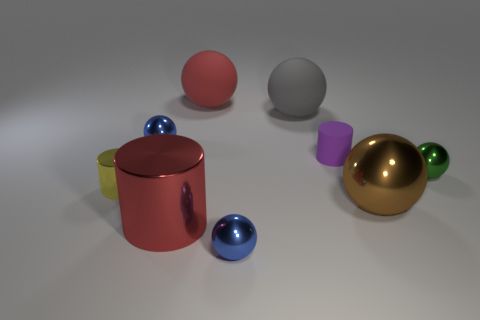Subtract all brown spheres. How many spheres are left? 5 Subtract all green balls. How many balls are left? 5 Subtract all purple balls. Subtract all blue blocks. How many balls are left? 6 Add 1 small green metallic balls. How many objects exist? 10 Subtract all cylinders. How many objects are left? 6 Add 4 big shiny balls. How many big shiny balls exist? 5 Subtract 1 green balls. How many objects are left? 8 Subtract all small blue things. Subtract all cylinders. How many objects are left? 4 Add 6 tiny purple cylinders. How many tiny purple cylinders are left? 7 